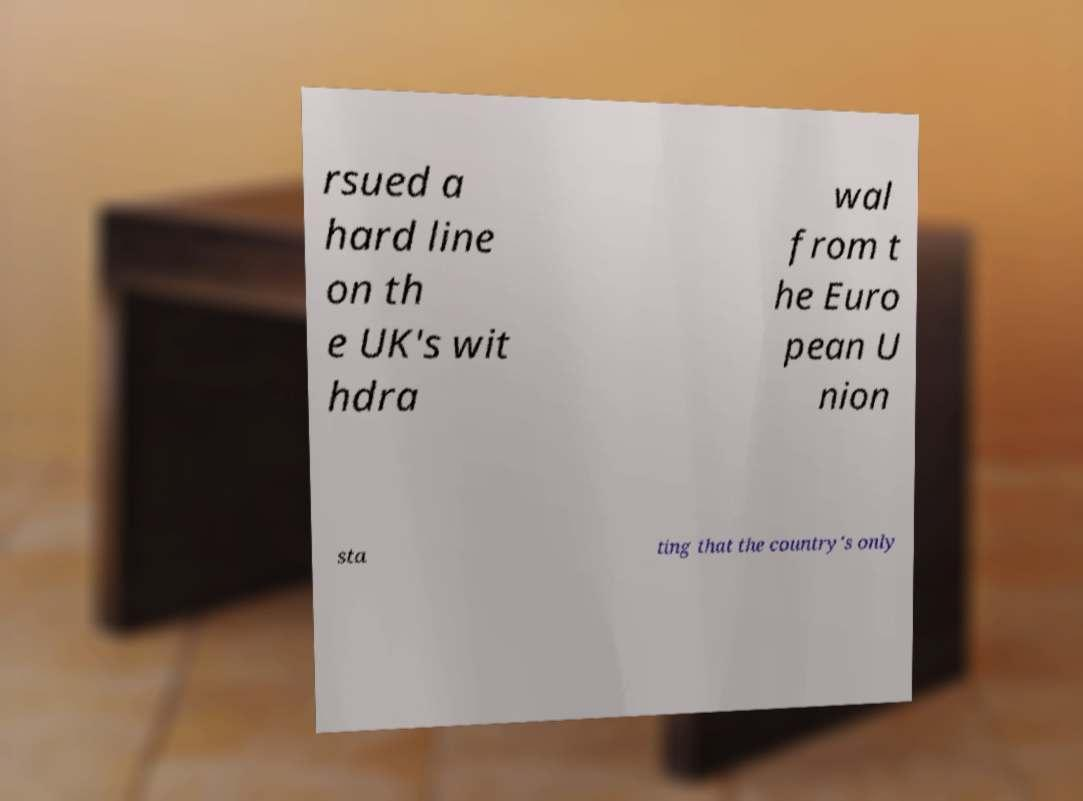Could you assist in decoding the text presented in this image and type it out clearly? rsued a hard line on th e UK's wit hdra wal from t he Euro pean U nion sta ting that the country's only 